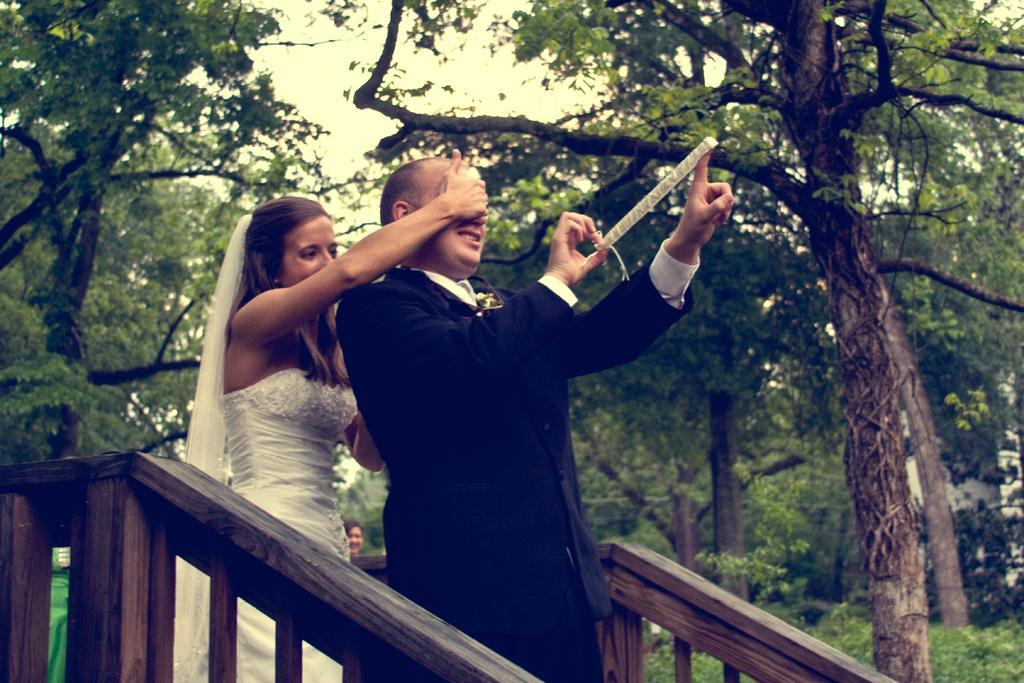Can you describe this image briefly? In this image we can see a woman closing the eyes of a man and the man is holding an object. Beside them, we can see the wooden railing. Behind them, we can see a person, group of trees and plants. At the top we can see the sky. 